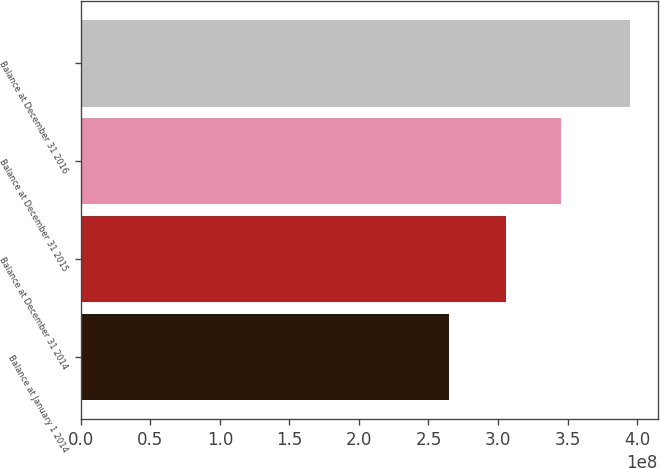<chart> <loc_0><loc_0><loc_500><loc_500><bar_chart><fcel>Balance at January 1 2014<fcel>Balance at December 31 2014<fcel>Balance at December 31 2015<fcel>Balance at December 31 2016<nl><fcel>2.64882e+08<fcel>3.05534e+08<fcel>3.45637e+08<fcel>3.9511e+08<nl></chart> 